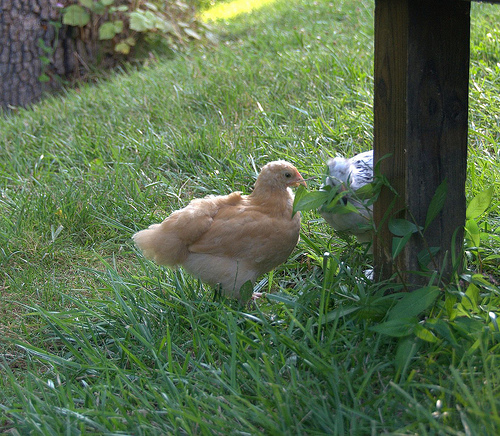<image>
Is the ken on the grass? Yes. Looking at the image, I can see the ken is positioned on top of the grass, with the grass providing support. Where is the chicken in relation to the leaf? Is it under the leaf? No. The chicken is not positioned under the leaf. The vertical relationship between these objects is different. Where is the hen in relation to the tree? Is it next to the tree? No. The hen is not positioned next to the tree. They are located in different areas of the scene. 